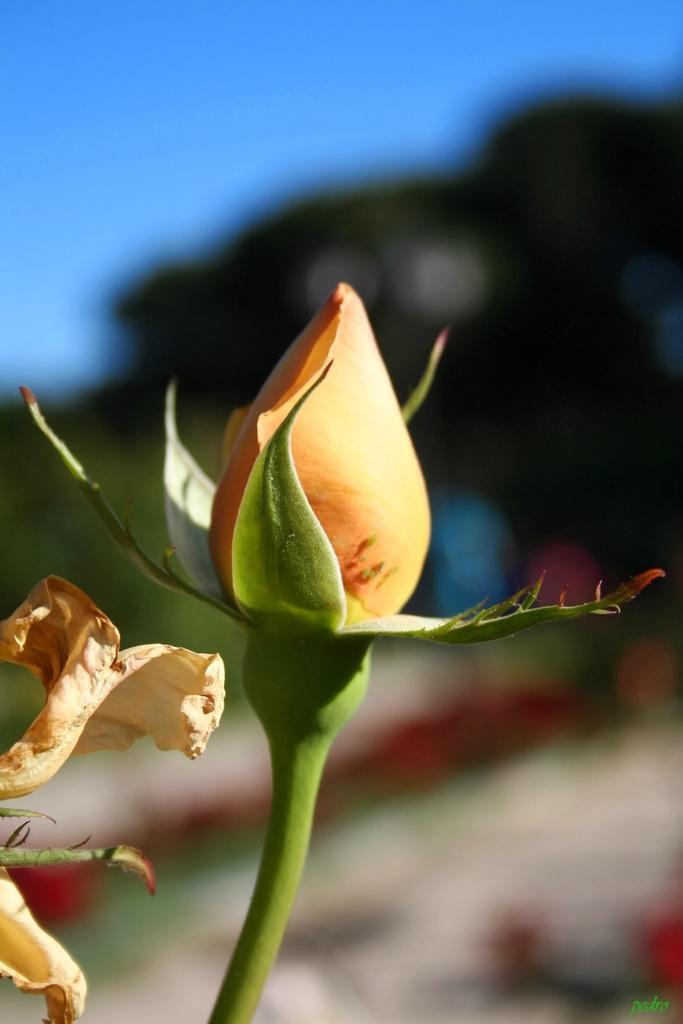Please provide a concise description of this image. In this image I can see there is a flower bud and there is another flower on to the left. In the backdrop I can see there are some trees and the sky is clear. 